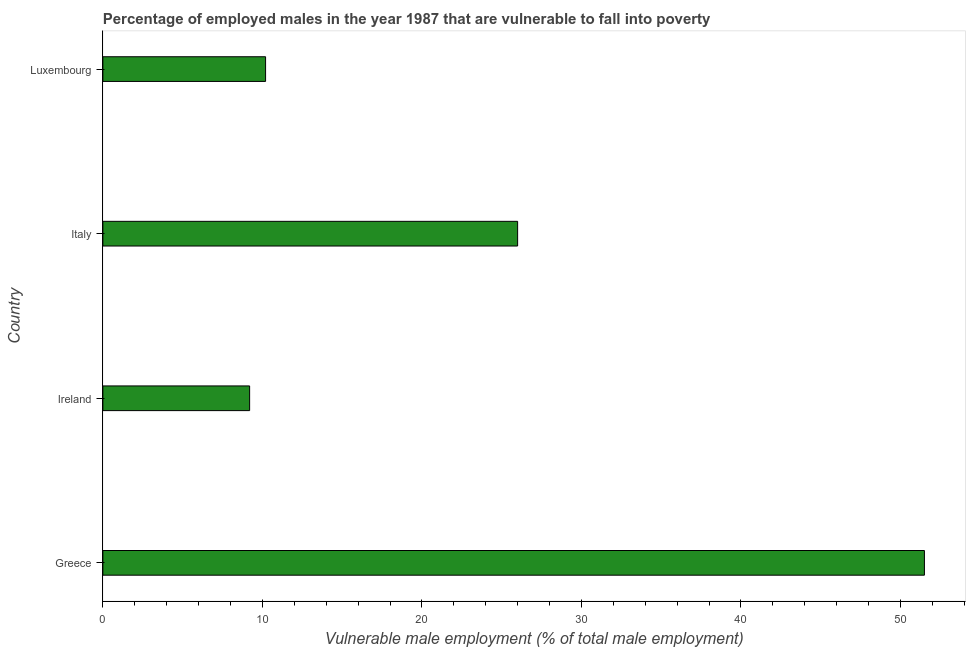Does the graph contain grids?
Keep it short and to the point. No. What is the title of the graph?
Make the answer very short. Percentage of employed males in the year 1987 that are vulnerable to fall into poverty. What is the label or title of the X-axis?
Give a very brief answer. Vulnerable male employment (% of total male employment). What is the label or title of the Y-axis?
Offer a terse response. Country. What is the percentage of employed males who are vulnerable to fall into poverty in Ireland?
Provide a short and direct response. 9.2. Across all countries, what is the maximum percentage of employed males who are vulnerable to fall into poverty?
Ensure brevity in your answer.  51.5. Across all countries, what is the minimum percentage of employed males who are vulnerable to fall into poverty?
Your response must be concise. 9.2. In which country was the percentage of employed males who are vulnerable to fall into poverty maximum?
Provide a succinct answer. Greece. In which country was the percentage of employed males who are vulnerable to fall into poverty minimum?
Provide a succinct answer. Ireland. What is the sum of the percentage of employed males who are vulnerable to fall into poverty?
Give a very brief answer. 96.9. What is the average percentage of employed males who are vulnerable to fall into poverty per country?
Your answer should be very brief. 24.23. What is the median percentage of employed males who are vulnerable to fall into poverty?
Offer a terse response. 18.1. What is the ratio of the percentage of employed males who are vulnerable to fall into poverty in Ireland to that in Italy?
Ensure brevity in your answer.  0.35. Is the percentage of employed males who are vulnerable to fall into poverty in Ireland less than that in Italy?
Provide a short and direct response. Yes. Is the difference between the percentage of employed males who are vulnerable to fall into poverty in Greece and Italy greater than the difference between any two countries?
Your response must be concise. No. What is the difference between the highest and the second highest percentage of employed males who are vulnerable to fall into poverty?
Provide a succinct answer. 25.5. What is the difference between the highest and the lowest percentage of employed males who are vulnerable to fall into poverty?
Ensure brevity in your answer.  42.3. How many bars are there?
Ensure brevity in your answer.  4. How many countries are there in the graph?
Your answer should be very brief. 4. What is the difference between two consecutive major ticks on the X-axis?
Make the answer very short. 10. What is the Vulnerable male employment (% of total male employment) in Greece?
Offer a very short reply. 51.5. What is the Vulnerable male employment (% of total male employment) of Ireland?
Ensure brevity in your answer.  9.2. What is the Vulnerable male employment (% of total male employment) in Luxembourg?
Offer a terse response. 10.2. What is the difference between the Vulnerable male employment (% of total male employment) in Greece and Ireland?
Your answer should be very brief. 42.3. What is the difference between the Vulnerable male employment (% of total male employment) in Greece and Luxembourg?
Make the answer very short. 41.3. What is the difference between the Vulnerable male employment (% of total male employment) in Ireland and Italy?
Make the answer very short. -16.8. What is the ratio of the Vulnerable male employment (% of total male employment) in Greece to that in Ireland?
Provide a succinct answer. 5.6. What is the ratio of the Vulnerable male employment (% of total male employment) in Greece to that in Italy?
Offer a terse response. 1.98. What is the ratio of the Vulnerable male employment (% of total male employment) in Greece to that in Luxembourg?
Your answer should be compact. 5.05. What is the ratio of the Vulnerable male employment (% of total male employment) in Ireland to that in Italy?
Ensure brevity in your answer.  0.35. What is the ratio of the Vulnerable male employment (% of total male employment) in Ireland to that in Luxembourg?
Your answer should be compact. 0.9. What is the ratio of the Vulnerable male employment (% of total male employment) in Italy to that in Luxembourg?
Ensure brevity in your answer.  2.55. 